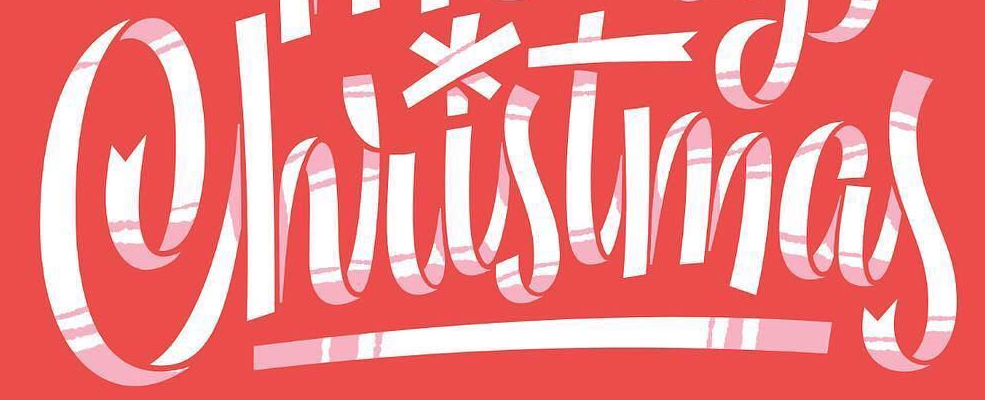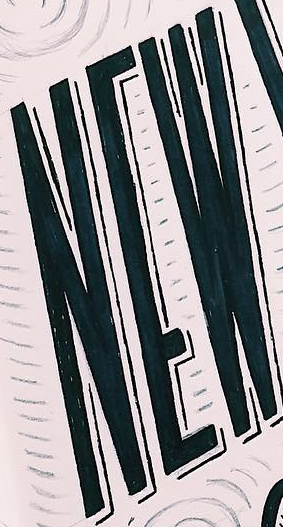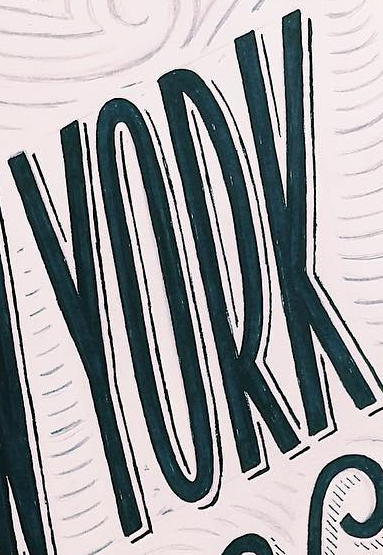Read the text content from these images in order, separated by a semicolon. Christmas; NEW; YORK 